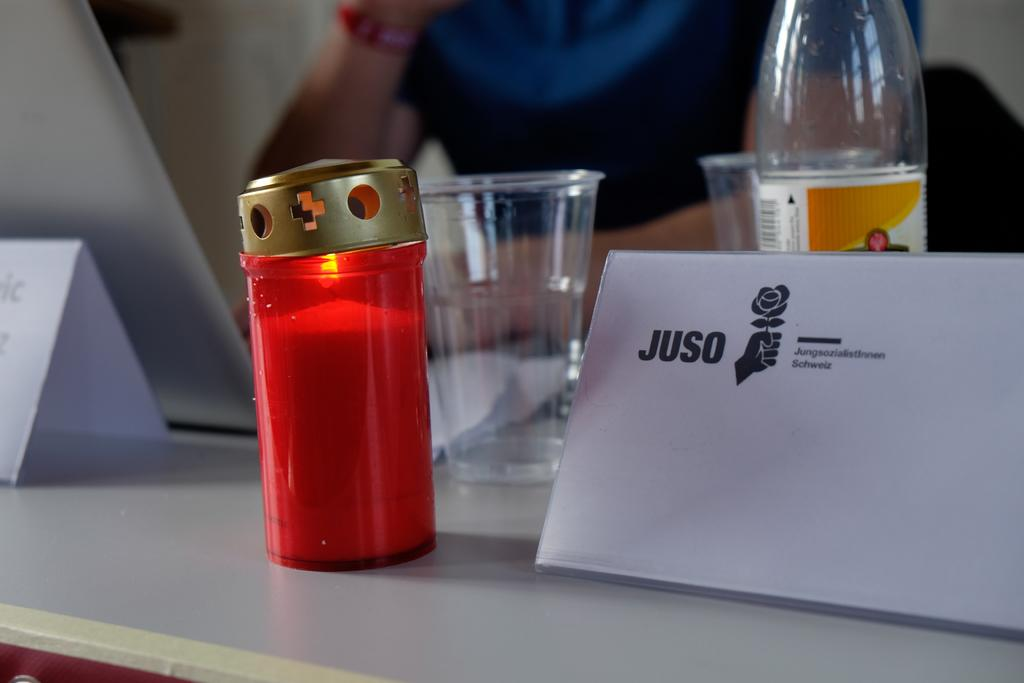Provide a one-sentence caption for the provided image. A candle sits alight on a small table at a conference. 